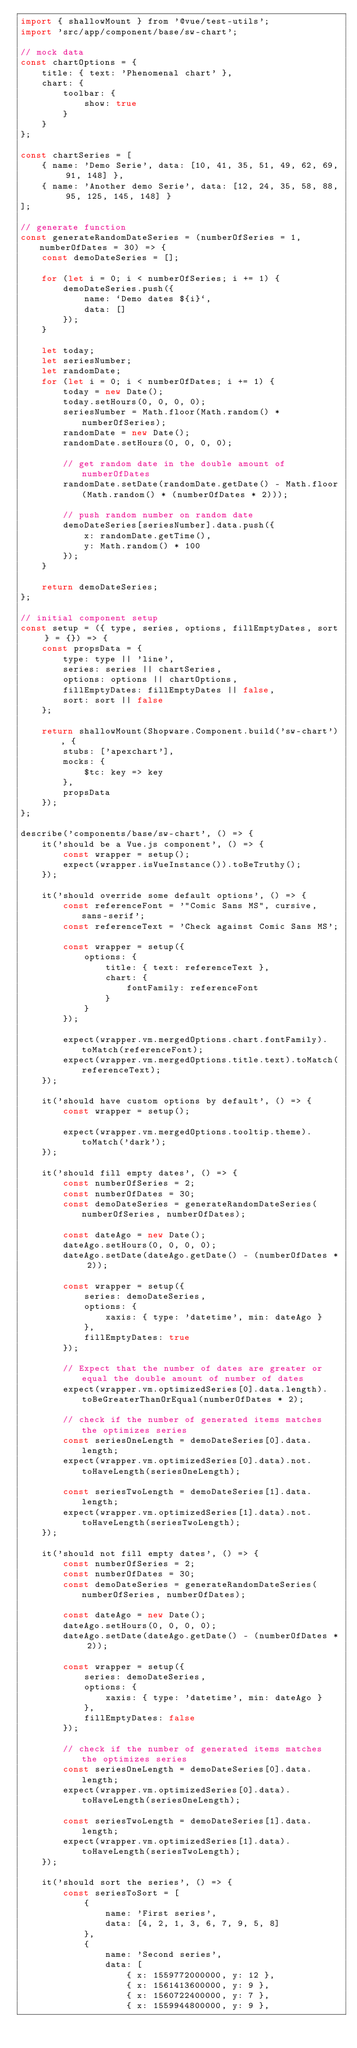<code> <loc_0><loc_0><loc_500><loc_500><_JavaScript_>import { shallowMount } from '@vue/test-utils';
import 'src/app/component/base/sw-chart';

// mock data
const chartOptions = {
    title: { text: 'Phenomenal chart' },
    chart: {
        toolbar: {
            show: true
        }
    }
};

const chartSeries = [
    { name: 'Demo Serie', data: [10, 41, 35, 51, 49, 62, 69, 91, 148] },
    { name: 'Another demo Serie', data: [12, 24, 35, 58, 88, 95, 125, 145, 148] }
];

// generate function
const generateRandomDateSeries = (numberOfSeries = 1, numberOfDates = 30) => {
    const demoDateSeries = [];

    for (let i = 0; i < numberOfSeries; i += 1) {
        demoDateSeries.push({
            name: `Demo dates ${i}`,
            data: []
        });
    }

    let today;
    let seriesNumber;
    let randomDate;
    for (let i = 0; i < numberOfDates; i += 1) {
        today = new Date();
        today.setHours(0, 0, 0, 0);
        seriesNumber = Math.floor(Math.random() * numberOfSeries);
        randomDate = new Date();
        randomDate.setHours(0, 0, 0, 0);

        // get random date in the double amount of numberOfDates
        randomDate.setDate(randomDate.getDate() - Math.floor(Math.random() * (numberOfDates * 2)));

        // push random number on random date
        demoDateSeries[seriesNumber].data.push({
            x: randomDate.getTime(),
            y: Math.random() * 100
        });
    }

    return demoDateSeries;
};

// initial component setup
const setup = ({ type, series, options, fillEmptyDates, sort } = {}) => {
    const propsData = {
        type: type || 'line',
        series: series || chartSeries,
        options: options || chartOptions,
        fillEmptyDates: fillEmptyDates || false,
        sort: sort || false
    };

    return shallowMount(Shopware.Component.build('sw-chart'), {
        stubs: ['apexchart'],
        mocks: {
            $tc: key => key
        },
        propsData
    });
};

describe('components/base/sw-chart', () => {
    it('should be a Vue.js component', () => {
        const wrapper = setup();
        expect(wrapper.isVueInstance()).toBeTruthy();
    });

    it('should override some default options', () => {
        const referenceFont = '"Comic Sans MS", cursive, sans-serif';
        const referenceText = 'Check against Comic Sans MS';

        const wrapper = setup({
            options: {
                title: { text: referenceText },
                chart: {
                    fontFamily: referenceFont
                }
            }
        });

        expect(wrapper.vm.mergedOptions.chart.fontFamily).toMatch(referenceFont);
        expect(wrapper.vm.mergedOptions.title.text).toMatch(referenceText);
    });

    it('should have custom options by default', () => {
        const wrapper = setup();

        expect(wrapper.vm.mergedOptions.tooltip.theme).toMatch('dark');
    });

    it('should fill empty dates', () => {
        const numberOfSeries = 2;
        const numberOfDates = 30;
        const demoDateSeries = generateRandomDateSeries(numberOfSeries, numberOfDates);

        const dateAgo = new Date();
        dateAgo.setHours(0, 0, 0, 0);
        dateAgo.setDate(dateAgo.getDate() - (numberOfDates * 2));

        const wrapper = setup({
            series: demoDateSeries,
            options: {
                xaxis: { type: 'datetime', min: dateAgo }
            },
            fillEmptyDates: true
        });

        // Expect that the number of dates are greater or equal the double amount of number of dates
        expect(wrapper.vm.optimizedSeries[0].data.length).toBeGreaterThanOrEqual(numberOfDates * 2);

        // check if the number of generated items matches the optimizes series
        const seriesOneLength = demoDateSeries[0].data.length;
        expect(wrapper.vm.optimizedSeries[0].data).not.toHaveLength(seriesOneLength);

        const seriesTwoLength = demoDateSeries[1].data.length;
        expect(wrapper.vm.optimizedSeries[1].data).not.toHaveLength(seriesTwoLength);
    });

    it('should not fill empty dates', () => {
        const numberOfSeries = 2;
        const numberOfDates = 30;
        const demoDateSeries = generateRandomDateSeries(numberOfSeries, numberOfDates);

        const dateAgo = new Date();
        dateAgo.setHours(0, 0, 0, 0);
        dateAgo.setDate(dateAgo.getDate() - (numberOfDates * 2));

        const wrapper = setup({
            series: demoDateSeries,
            options: {
                xaxis: { type: 'datetime', min: dateAgo }
            },
            fillEmptyDates: false
        });

        // check if the number of generated items matches the optimizes series
        const seriesOneLength = demoDateSeries[0].data.length;
        expect(wrapper.vm.optimizedSeries[0].data).toHaveLength(seriesOneLength);

        const seriesTwoLength = demoDateSeries[1].data.length;
        expect(wrapper.vm.optimizedSeries[1].data).toHaveLength(seriesTwoLength);
    });

    it('should sort the series', () => {
        const seriesToSort = [
            {
                name: 'First series',
                data: [4, 2, 1, 3, 6, 7, 9, 5, 8]
            },
            {
                name: 'Second series',
                data: [
                    { x: 1559772000000, y: 12 },
                    { x: 1561413600000, y: 9 },
                    { x: 1560722400000, y: 7 },
                    { x: 1559944800000, y: 9 },</code> 